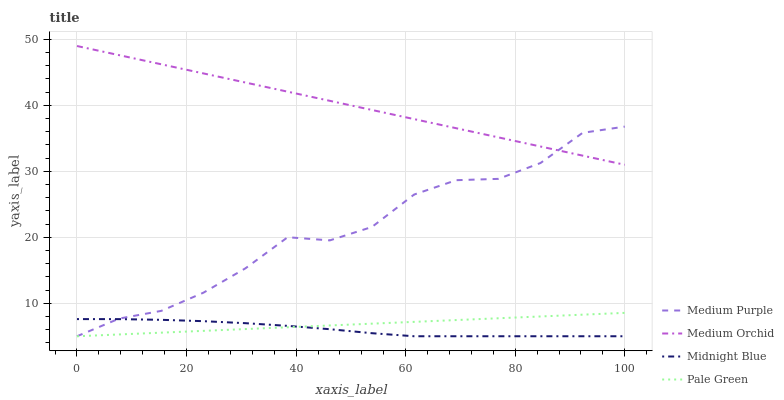Does Pale Green have the minimum area under the curve?
Answer yes or no. No. Does Pale Green have the maximum area under the curve?
Answer yes or no. No. Is Medium Orchid the smoothest?
Answer yes or no. No. Is Medium Orchid the roughest?
Answer yes or no. No. Does Medium Orchid have the lowest value?
Answer yes or no. No. Does Pale Green have the highest value?
Answer yes or no. No. Is Midnight Blue less than Medium Orchid?
Answer yes or no. Yes. Is Medium Orchid greater than Pale Green?
Answer yes or no. Yes. Does Midnight Blue intersect Medium Orchid?
Answer yes or no. No. 